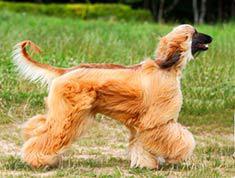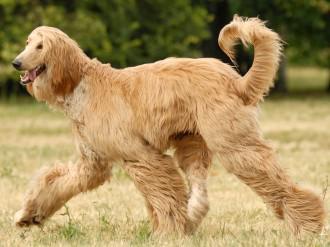The first image is the image on the left, the second image is the image on the right. For the images displayed, is the sentence "There are two dogs facing each other." factually correct? Answer yes or no. Yes. The first image is the image on the left, the second image is the image on the right. For the images displayed, is the sentence "2 walking dogs have curled tails." factually correct? Answer yes or no. Yes. 